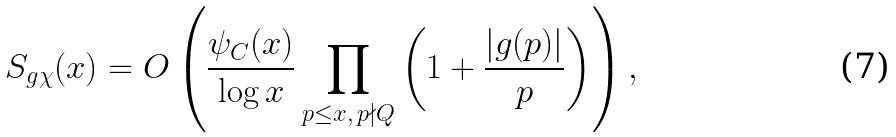<formula> <loc_0><loc_0><loc_500><loc_500>S _ { g \chi } ( x ) = O \left ( \frac { \psi _ { C } ( x ) } { \log x } \prod _ { \substack { p \leq x , \, p \nmid Q } } \left ( 1 + \frac { | g ( p ) | } { p } \right ) \right ) ,</formula> 